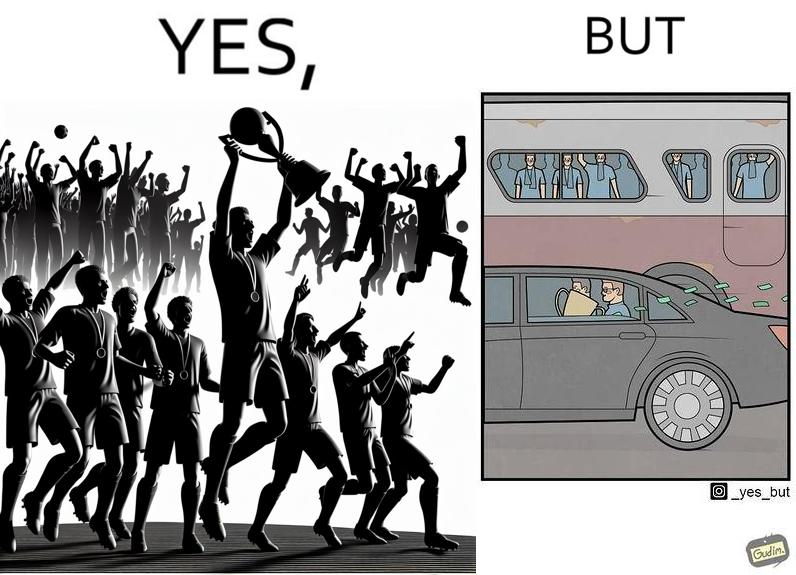Is this image satirical or non-satirical? Yes, this image is satirical. 